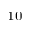<formula> <loc_0><loc_0><loc_500><loc_500>_ { 1 0 }</formula> 